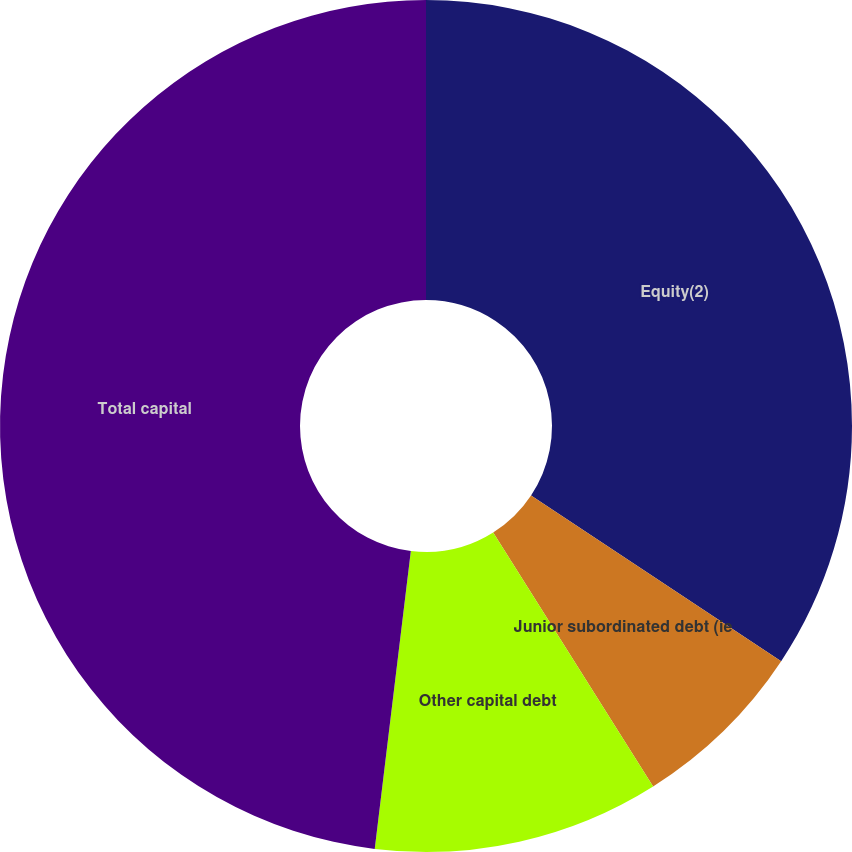Convert chart to OTSL. <chart><loc_0><loc_0><loc_500><loc_500><pie_chart><fcel>Equity(2)<fcel>Junior subordinated debt (ie<fcel>Other capital debt<fcel>Total capital<nl><fcel>34.31%<fcel>6.74%<fcel>10.87%<fcel>48.08%<nl></chart> 